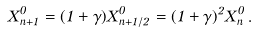<formula> <loc_0><loc_0><loc_500><loc_500>X ^ { 0 } _ { n + 1 } = ( 1 + \gamma ) X ^ { 0 } _ { n + 1 / 2 } = ( 1 + \gamma ) ^ { 2 } X ^ { 0 } _ { n } \, .</formula> 